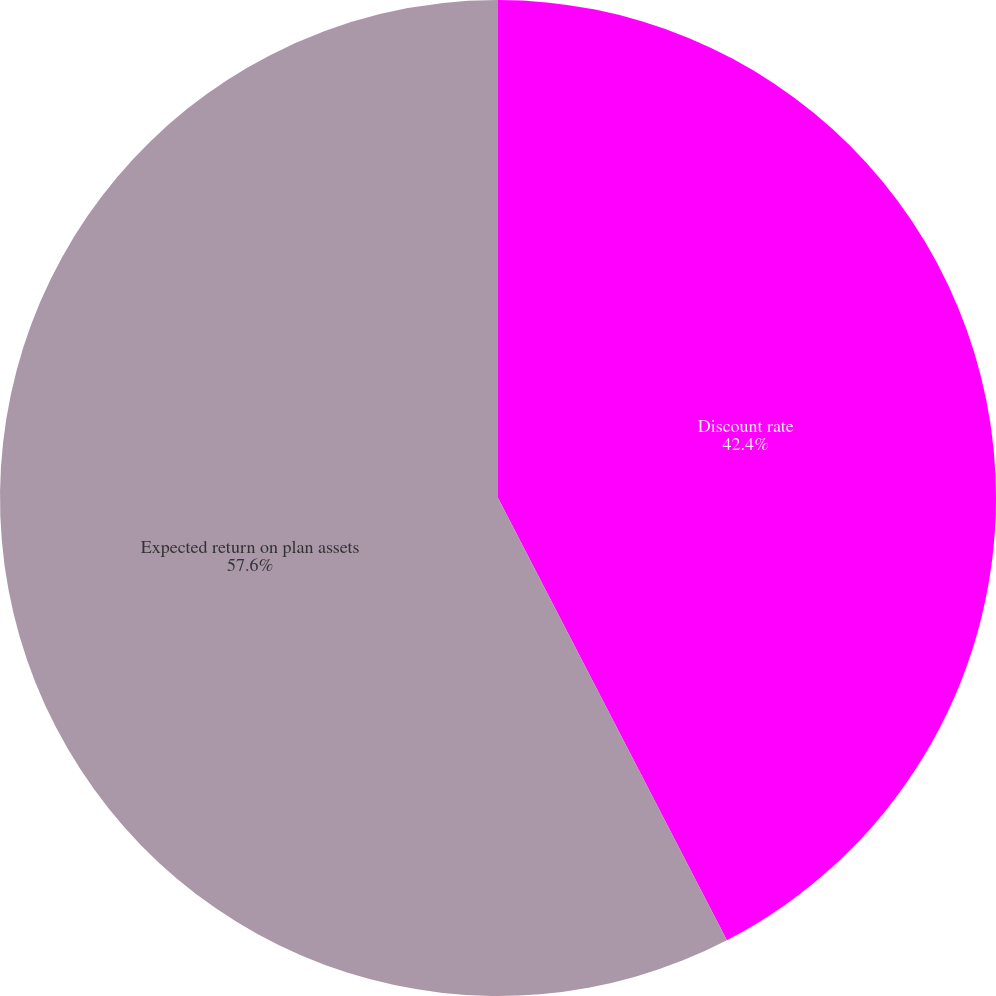Convert chart. <chart><loc_0><loc_0><loc_500><loc_500><pie_chart><fcel>Discount rate<fcel>Expected return on plan assets<nl><fcel>42.4%<fcel>57.6%<nl></chart> 